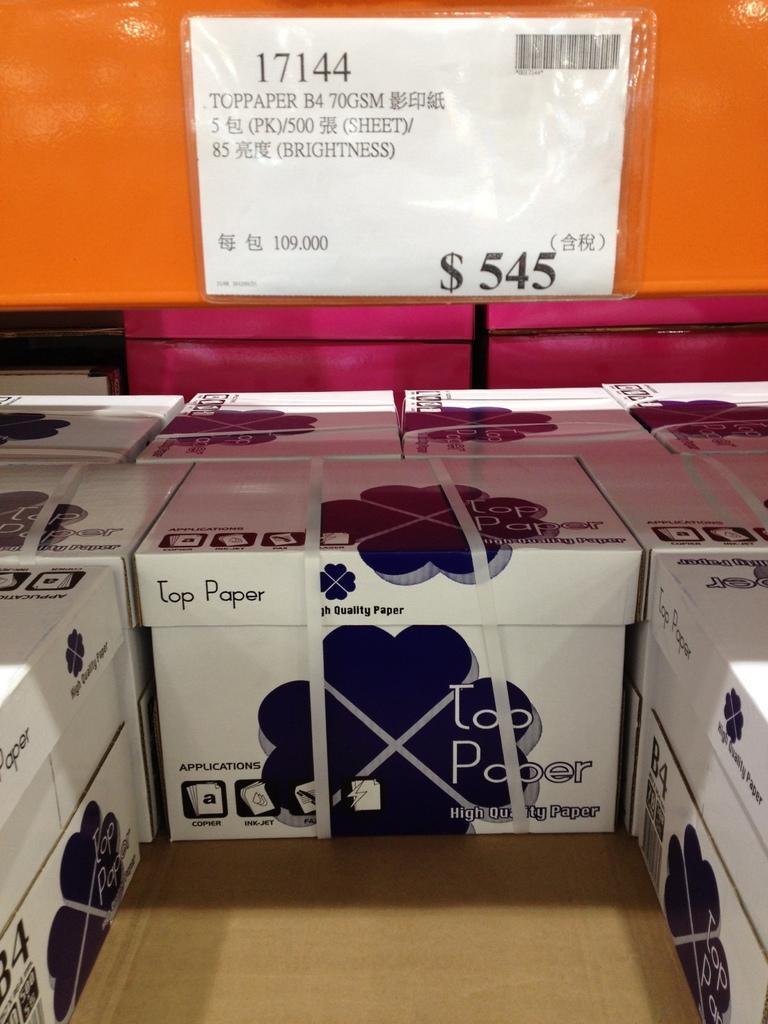Describe this image in one or two sentences. In this picture there are cardboard boxes and there is a text and there is a logo on the boxes. At the top there is a paper on the board. On the paper there is a price and there is a bar code. 